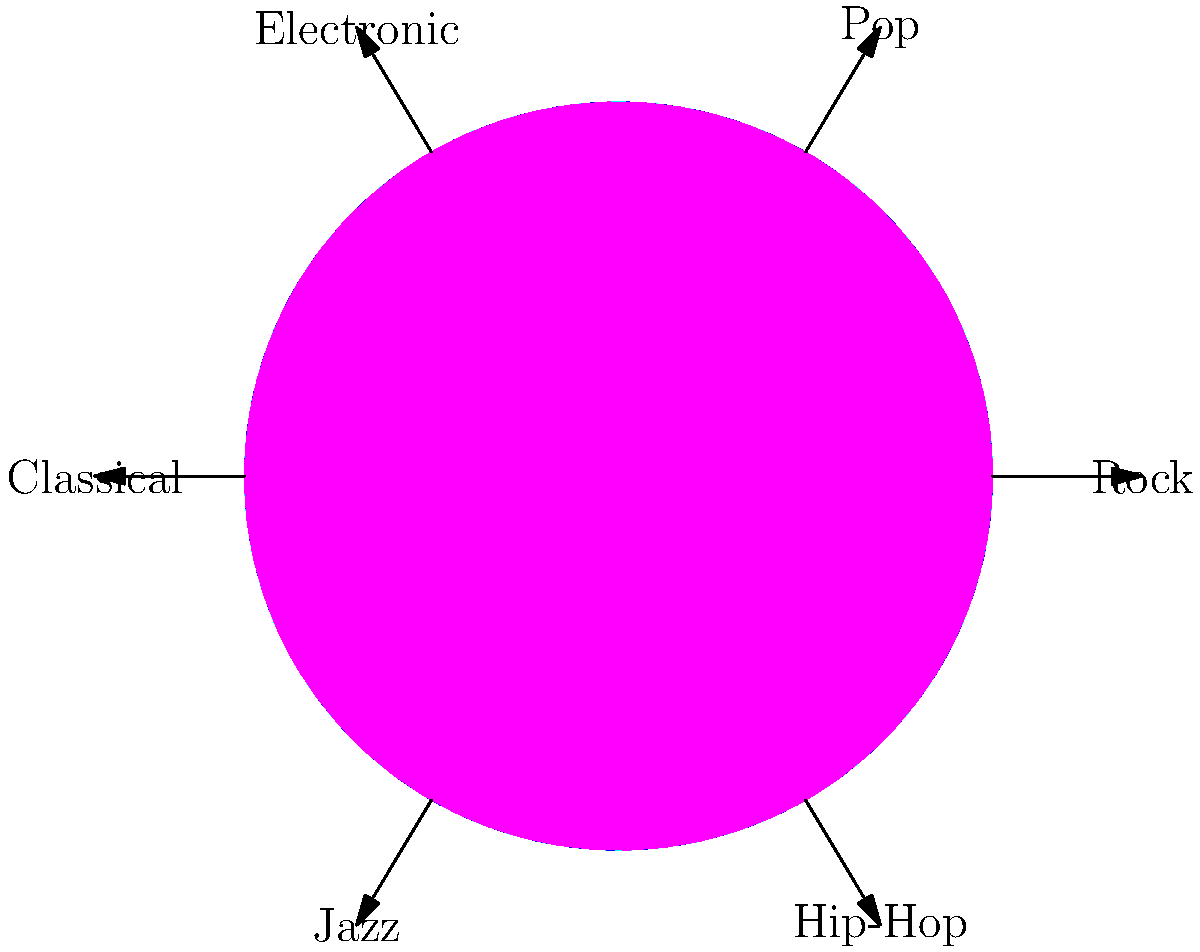As a fashion designer who merges music and fashion, you're working on a new collection inspired by different musical genres. Using the color wheel and genre labels provided, which color palette would be most appropriate for a Classical music-inspired clothing line? To determine the most appropriate color palette for a Classical music-inspired clothing line, we need to follow these steps:

1. Locate the "Classical" genre on the diagram: It's positioned on the left side of the color wheel.

2. Identify the colors closest to the Classical label: The colors adjacent to the Classical label are blue and blue-green (cyan).

3. Consider the characteristics of Classical music:
   - Often associated with elegance, sophistication, and tradition
   - Typically evokes a sense of calmness and refined emotion

4. Analyze the psychological effects of blue and blue-green:
   - Blue: Often associated with calmness, serenity, and depth
   - Blue-green: Combines the tranquility of blue with the freshness of green

5. Consider complementary colors:
   - The complementary color to blue is orange (located opposite on the color wheel)
   - This could be used as an accent color for contrast and visual interest

6. Determine the final color palette:
   - Primary colors: Various shades of blue and blue-green
   - Accent color: Touches of orange or gold for contrast and elegance

This color palette reflects the serene and sophisticated nature of Classical music while providing enough contrast to create visually interesting and fashion-forward designs.
Answer: Blue and blue-green with orange/gold accents 